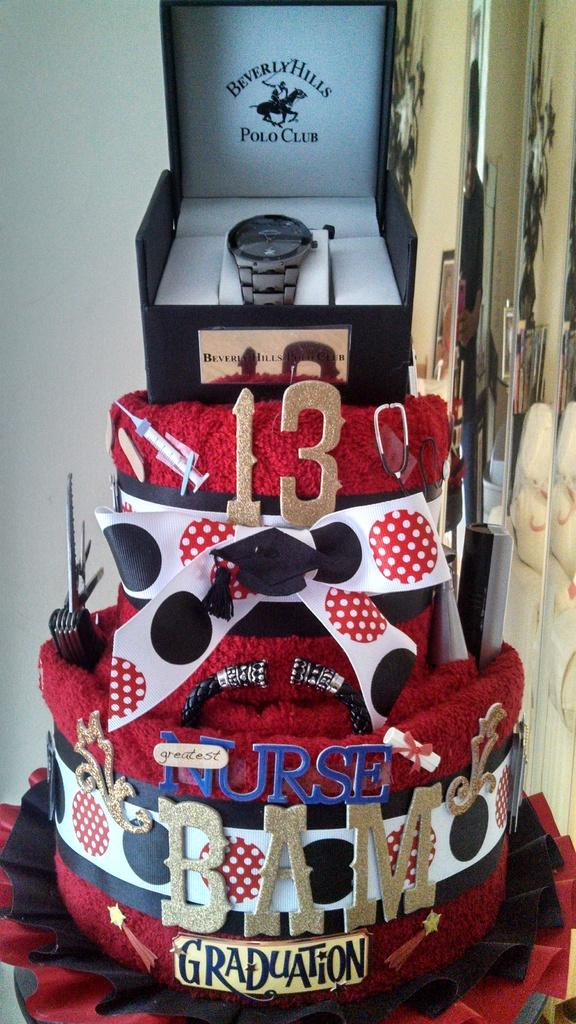<image>
Render a clear and concise summary of the photo. Polo Club watch on top of a red cake. 